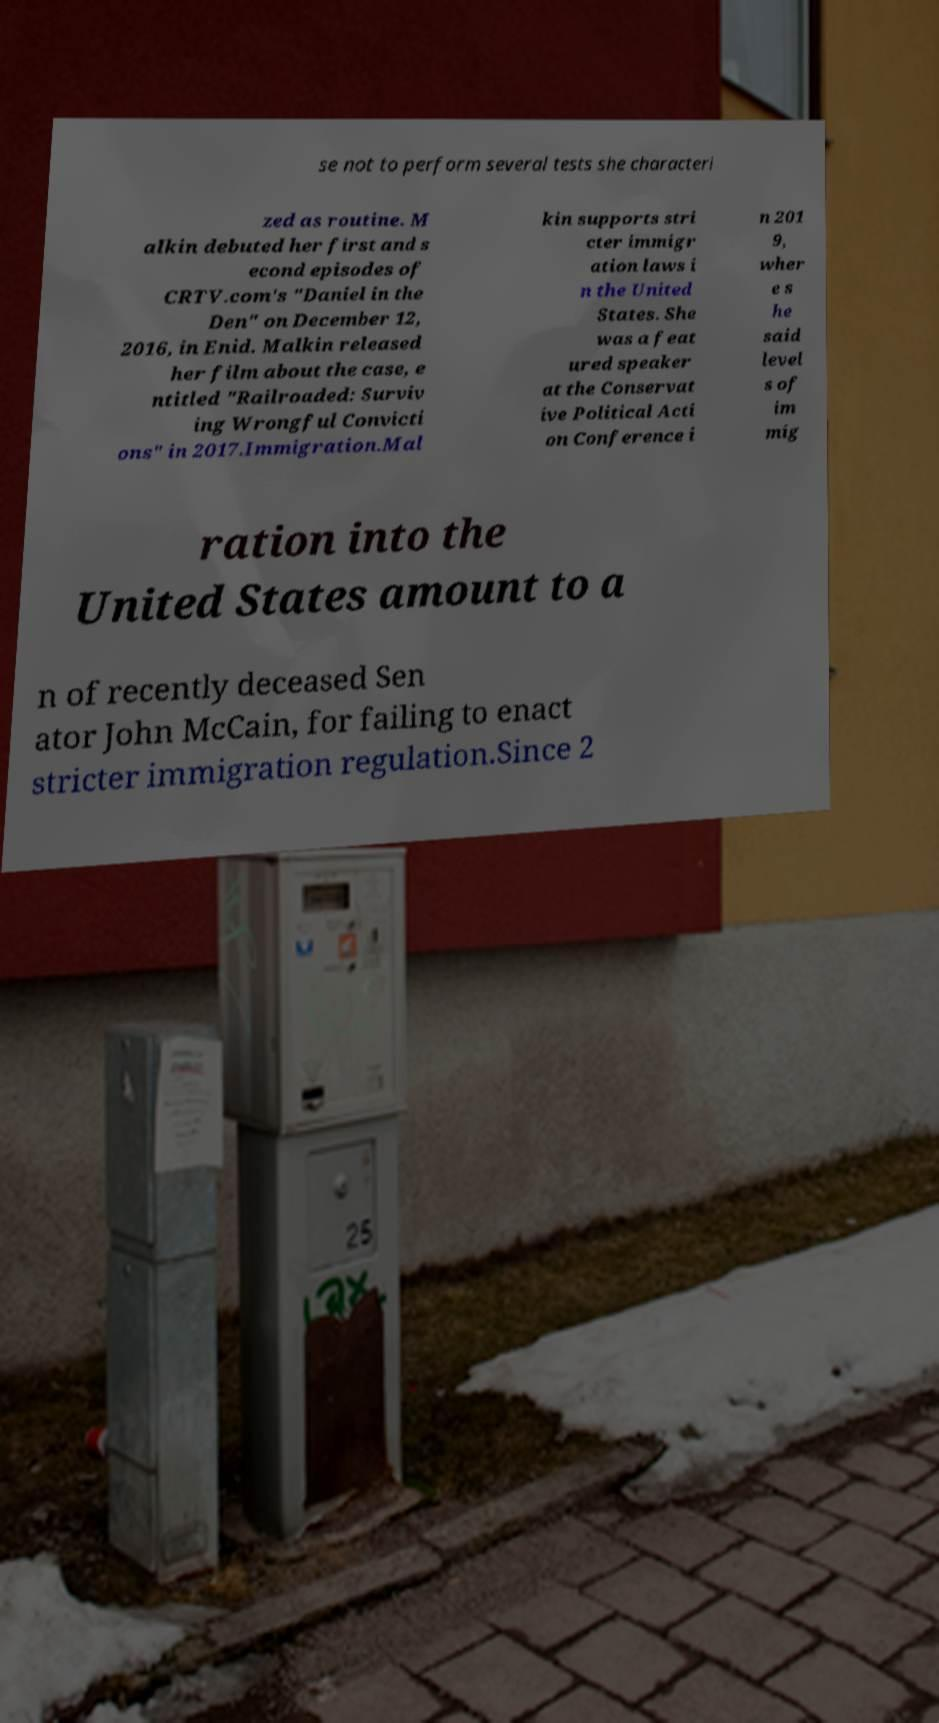Can you accurately transcribe the text from the provided image for me? se not to perform several tests she characteri zed as routine. M alkin debuted her first and s econd episodes of CRTV.com's "Daniel in the Den" on December 12, 2016, in Enid. Malkin released her film about the case, e ntitled "Railroaded: Surviv ing Wrongful Convicti ons" in 2017.Immigration.Mal kin supports stri cter immigr ation laws i n the United States. She was a feat ured speaker at the Conservat ive Political Acti on Conference i n 201 9, wher e s he said level s of im mig ration into the United States amount to a n of recently deceased Sen ator John McCain, for failing to enact stricter immigration regulation.Since 2 